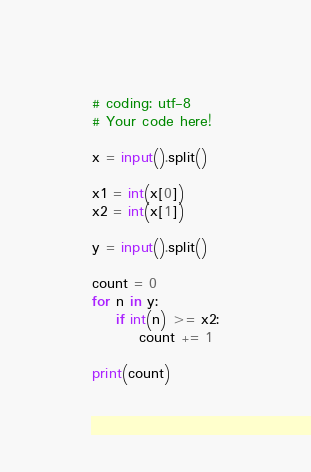Convert code to text. <code><loc_0><loc_0><loc_500><loc_500><_Python_># coding: utf-8
# Your code here!

x = input().split()

x1 = int(x[0])
x2 = int(x[1])

y = input().split()

count = 0
for n in y:
    if int(n) >= x2:
        count += 1

print(count)</code> 